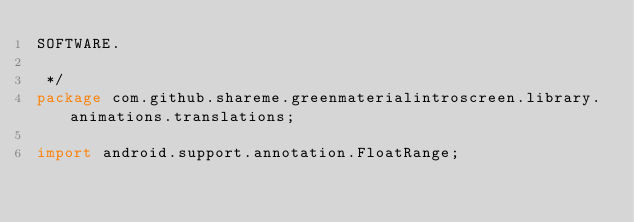Convert code to text. <code><loc_0><loc_0><loc_500><loc_500><_Java_>SOFTWARE.

 */
package com.github.shareme.greenmaterialintroscreen.library.animations.translations;

import android.support.annotation.FloatRange;</code> 